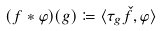<formula> <loc_0><loc_0><loc_500><loc_500>( f \ast \varphi ) ( g ) \coloneqq \langle \tau _ { g } \check { f } , \varphi \rangle</formula> 